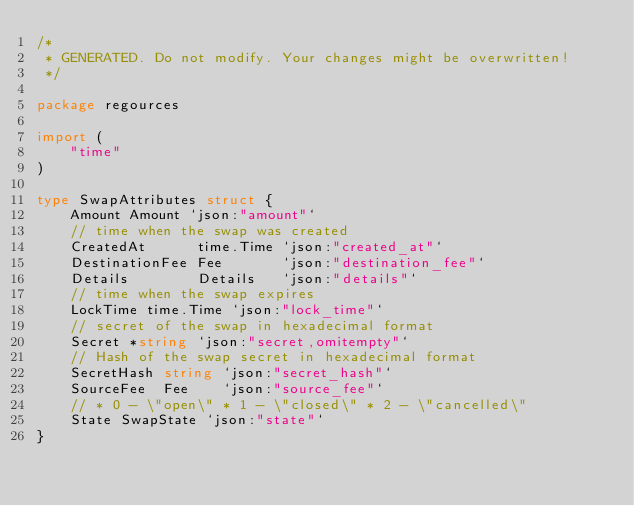Convert code to text. <code><loc_0><loc_0><loc_500><loc_500><_Go_>/*
 * GENERATED. Do not modify. Your changes might be overwritten!
 */

package regources

import (
	"time"
)

type SwapAttributes struct {
	Amount Amount `json:"amount"`
	// time when the swap was created
	CreatedAt      time.Time `json:"created_at"`
	DestinationFee Fee       `json:"destination_fee"`
	Details        Details   `json:"details"`
	// time when the swap expires
	LockTime time.Time `json:"lock_time"`
	// secret of the swap in hexadecimal format
	Secret *string `json:"secret,omitempty"`
	// Hash of the swap secret in hexadecimal format
	SecretHash string `json:"secret_hash"`
	SourceFee  Fee    `json:"source_fee"`
	// * 0 - \"open\" * 1 - \"closed\" * 2 - \"cancelled\"
	State SwapState `json:"state"`
}
</code> 